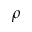<formula> <loc_0><loc_0><loc_500><loc_500>\rho</formula> 